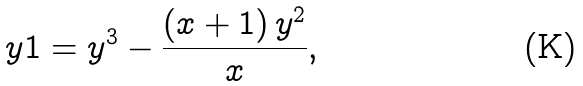<formula> <loc_0><loc_0><loc_500><loc_500>\ y 1 = { y } ^ { 3 } - { \frac { \left ( x + 1 \right ) { y } ^ { 2 } } { x } } ,</formula> 